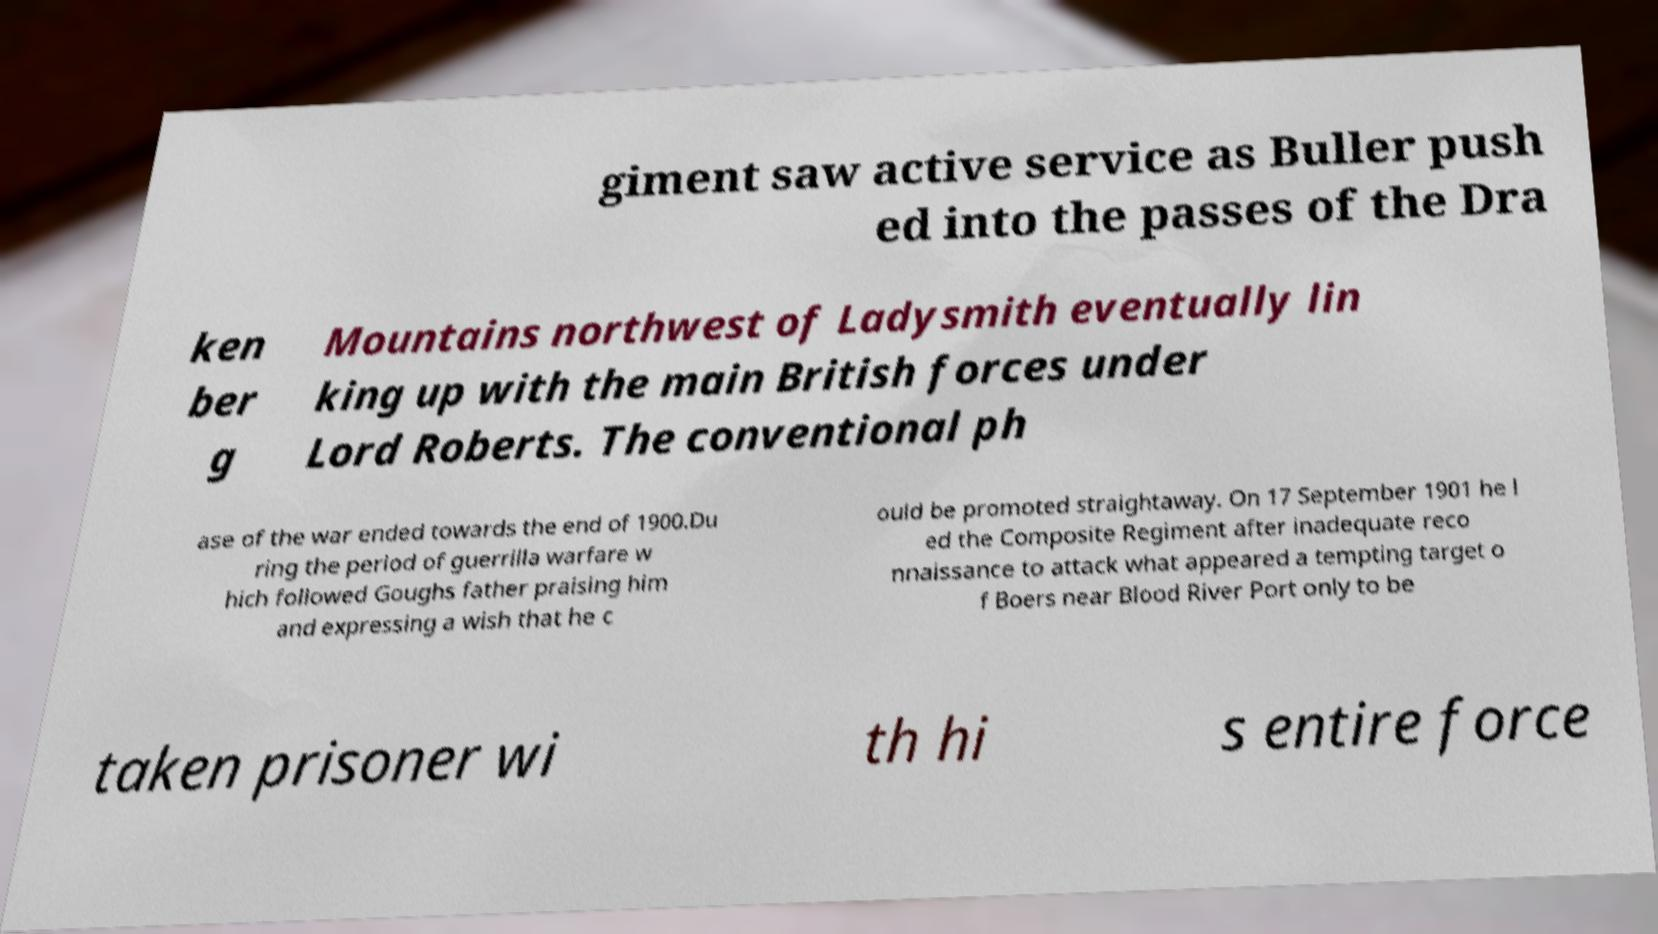Can you accurately transcribe the text from the provided image for me? giment saw active service as Buller push ed into the passes of the Dra ken ber g Mountains northwest of Ladysmith eventually lin king up with the main British forces under Lord Roberts. The conventional ph ase of the war ended towards the end of 1900.Du ring the period of guerrilla warfare w hich followed Goughs father praising him and expressing a wish that he c ould be promoted straightaway. On 17 September 1901 he l ed the Composite Regiment after inadequate reco nnaissance to attack what appeared a tempting target o f Boers near Blood River Port only to be taken prisoner wi th hi s entire force 